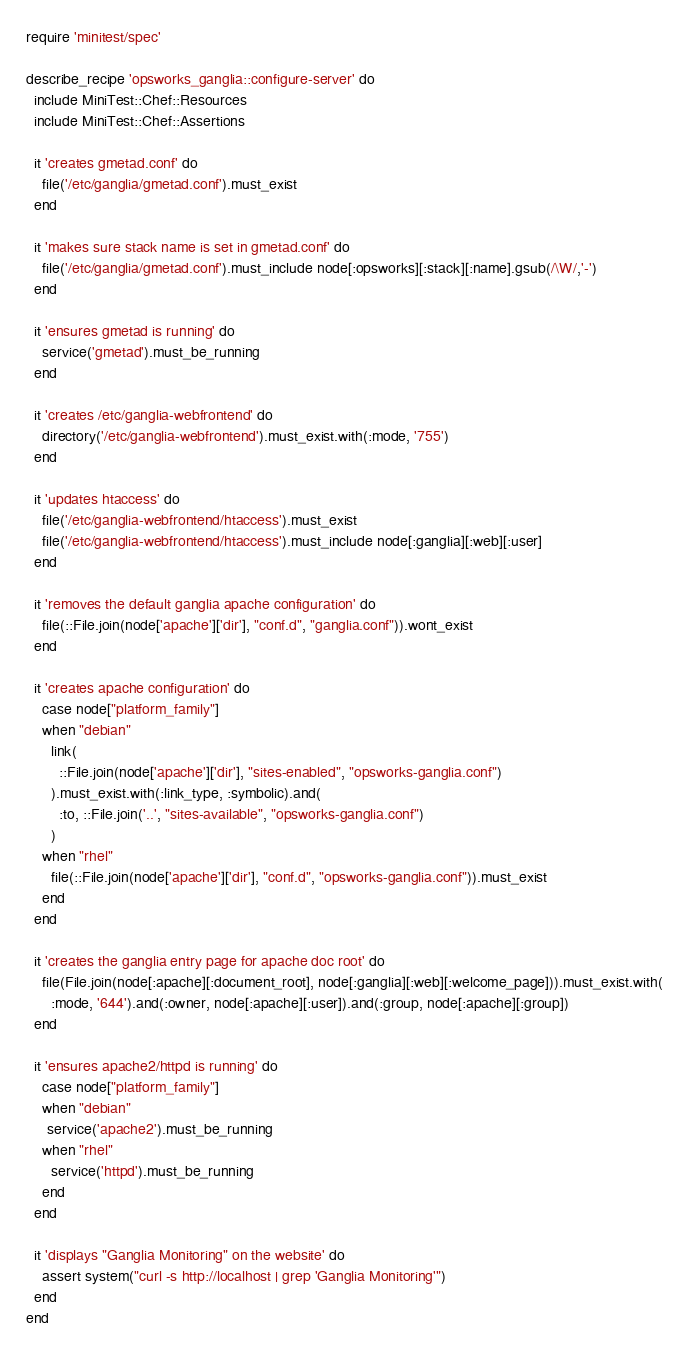Convert code to text. <code><loc_0><loc_0><loc_500><loc_500><_Ruby_>require 'minitest/spec'

describe_recipe 'opsworks_ganglia::configure-server' do
  include MiniTest::Chef::Resources
  include MiniTest::Chef::Assertions

  it 'creates gmetad.conf' do
    file('/etc/ganglia/gmetad.conf').must_exist
  end

  it 'makes sure stack name is set in gmetad.conf' do
    file('/etc/ganglia/gmetad.conf').must_include node[:opsworks][:stack][:name].gsub(/\W/,'-')
  end

  it 'ensures gmetad is running' do
    service('gmetad').must_be_running
  end

  it 'creates /etc/ganglia-webfrontend' do
    directory('/etc/ganglia-webfrontend').must_exist.with(:mode, '755')
  end

  it 'updates htaccess' do
    file('/etc/ganglia-webfrontend/htaccess').must_exist
    file('/etc/ganglia-webfrontend/htaccess').must_include node[:ganglia][:web][:user]
  end

  it 'removes the default ganglia apache configuration' do
    file(::File.join(node['apache']['dir'], "conf.d", "ganglia.conf")).wont_exist
  end

  it 'creates apache configuration' do
    case node["platform_family"]
    when "debian"
      link(
        ::File.join(node['apache']['dir'], "sites-enabled", "opsworks-ganglia.conf")
      ).must_exist.with(:link_type, :symbolic).and(
        :to, ::File.join('..', "sites-available", "opsworks-ganglia.conf")
      )
    when "rhel"
      file(::File.join(node['apache']['dir'], "conf.d", "opsworks-ganglia.conf")).must_exist
    end
  end

  it 'creates the ganglia entry page for apache doc root' do
    file(File.join(node[:apache][:document_root], node[:ganglia][:web][:welcome_page])).must_exist.with(
      :mode, '644').and(:owner, node[:apache][:user]).and(:group, node[:apache][:group])
  end

  it 'ensures apache2/httpd is running' do
    case node["platform_family"]
    when "debian"
     service('apache2').must_be_running
    when "rhel"
      service('httpd').must_be_running
    end
  end

  it 'displays "Ganglia Monitoring" on the website' do
    assert system("curl -s http://localhost | grep 'Ganglia Monitoring'")
  end
end
</code> 